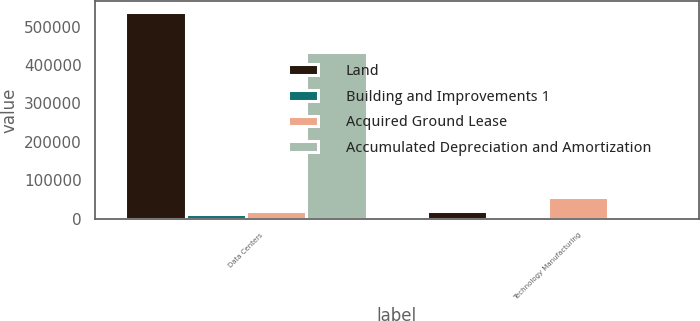<chart> <loc_0><loc_0><loc_500><loc_500><stacked_bar_chart><ecel><fcel>Data Centers<fcel>Technology Manufacturing<nl><fcel>Land<fcel>539298<fcel>20199<nl><fcel>Building and Improvements 1<fcel>11317<fcel>1322<nl><fcel>Acquired Ground Lease<fcel>20199<fcel>56254<nl><fcel>Accumulated Depreciation and Amortization<fcel>433679<fcel>6333<nl></chart> 